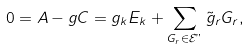Convert formula to latex. <formula><loc_0><loc_0><loc_500><loc_500>0 = A - g C = g _ { k } E _ { k } + \sum _ { G _ { r } \in { \mathcal { E } " } } \tilde { g } _ { r } G _ { r } ,</formula> 